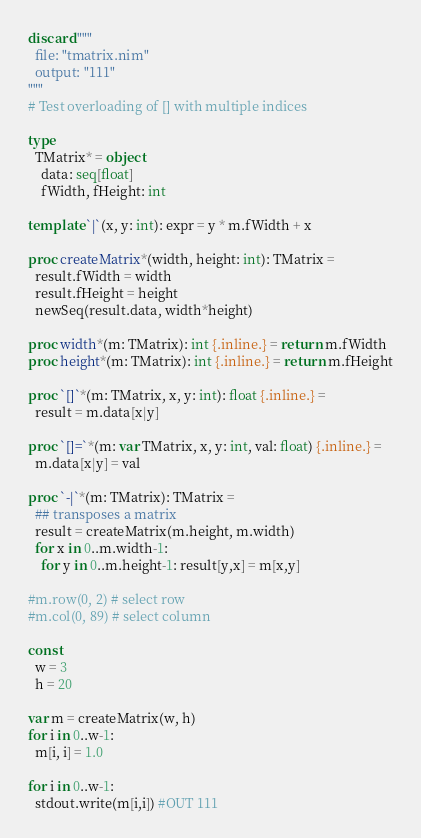Convert code to text. <code><loc_0><loc_0><loc_500><loc_500><_Nim_>discard """
  file: "tmatrix.nim"
  output: "111"
"""
# Test overloading of [] with multiple indices

type
  TMatrix* = object
    data: seq[float]
    fWidth, fHeight: int

template `|`(x, y: int): expr = y * m.fWidth + x

proc createMatrix*(width, height: int): TMatrix = 
  result.fWidth = width
  result.fHeight = height
  newSeq(result.data, width*height)

proc width*(m: TMatrix): int {.inline.} = return m.fWidth
proc height*(m: TMatrix): int {.inline.} = return m.fHeight

proc `[]`*(m: TMatrix, x, y: int): float {.inline.} =
  result = m.data[x|y]

proc `[]=`*(m: var TMatrix, x, y: int, val: float) {.inline.} =
  m.data[x|y] = val
  
proc `-|`*(m: TMatrix): TMatrix =
  ## transposes a matrix
  result = createMatrix(m.height, m.width)
  for x in 0..m.width-1:
    for y in 0..m.height-1: result[y,x] = m[x,y]

#m.row(0, 2) # select row
#m.col(0, 89) # select column

const
  w = 3
  h = 20

var m = createMatrix(w, h)
for i in 0..w-1:
  m[i, i] = 1.0

for i in 0..w-1:
  stdout.write(m[i,i]) #OUT 111


</code> 